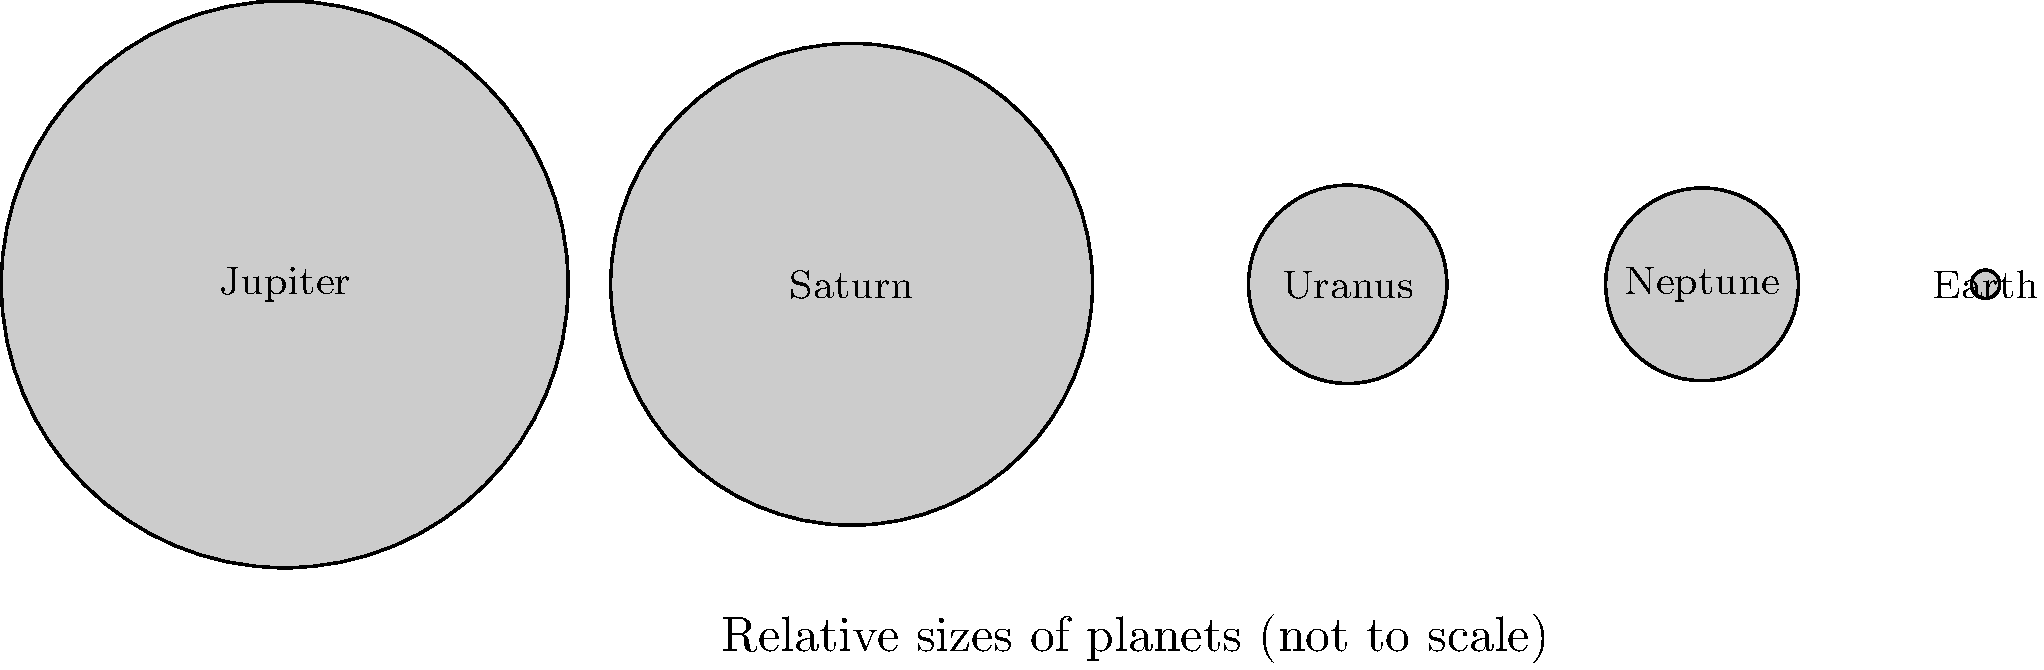In the tapestry of our solar system, planets weave a story of cosmic proportions. Considering the relative sizes depicted, which planet might symbolize the weight of wisdom in life's grand design, and why might its position be significant to our earthly perspective? To answer this question, let's consider the following steps:

1. Observe the relative sizes of the planets shown:
   Jupiter > Saturn > Uranus ≈ Neptune > Earth

2. Jupiter, being the largest, stands out as a potential symbol of wisdom due to its imposing presence.

3. In many cultures, wisdom is associated with age and experience. Jupiter, as the largest planet, could metaphorically represent accumulated knowledge.

4. Jupiter's position in the diagram, at the far left, could symbolize it being the first major influence or teacher in life's journey from left to right.

5. From Earth's perspective (the smallest planet shown), Jupiter would appear as a distant, yet significant celestial body – much like how wisdom often seems elusive yet profound in our lives.

6. In tailoring terms, we might liken Jupiter to a master tailor, whose vast experience and skill overshadow apprentices, yet remains an inspiration and guide.

7. The placement of Earth at the far right could represent our current position in life, looking back at the "wisdom" of Jupiter as we navigate our own path.

This interpretation aligns with the persona of a retired tailor who enjoys deep conversations about life, as it draws parallels between cosmic scale and human experience, inviting contemplation on the nature of wisdom and our place in the universe.
Answer: Jupiter symbolizes wisdom, its leftmost position representing foundational influence in life's journey. 